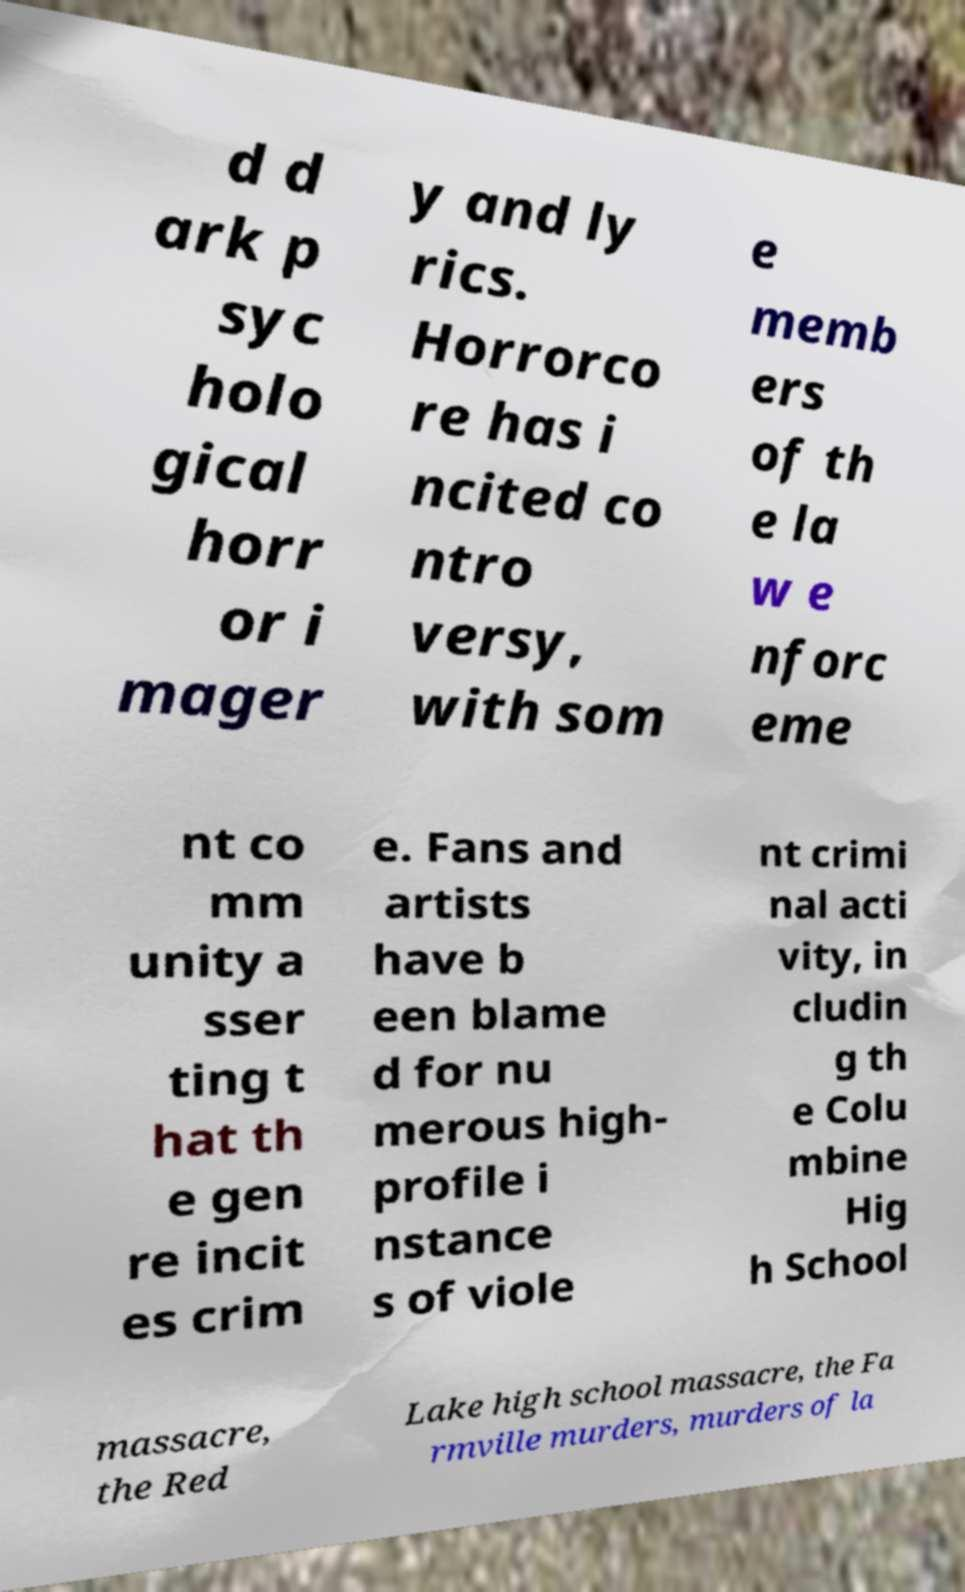Could you assist in decoding the text presented in this image and type it out clearly? d d ark p syc holo gical horr or i mager y and ly rics. Horrorco re has i ncited co ntro versy, with som e memb ers of th e la w e nforc eme nt co mm unity a sser ting t hat th e gen re incit es crim e. Fans and artists have b een blame d for nu merous high- profile i nstance s of viole nt crimi nal acti vity, in cludin g th e Colu mbine Hig h School massacre, the Red Lake high school massacre, the Fa rmville murders, murders of la 